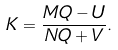Convert formula to latex. <formula><loc_0><loc_0><loc_500><loc_500>K = \frac { M Q - U } { N Q + V } .</formula> 